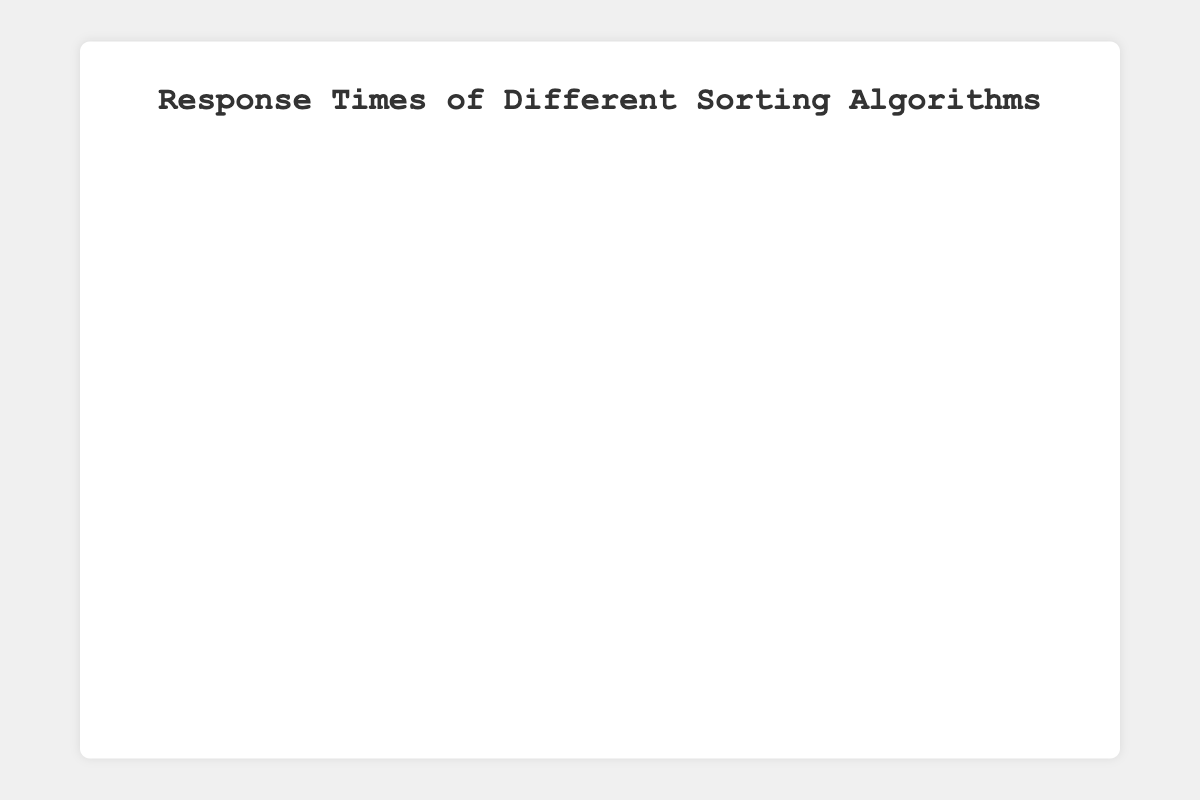What is the title of the chart? The title can be found at the top of the chart in a larger font size, and it typically provides an overview or description of what the chart is about. Here, the title reads "Response Times of Different Sorting Algorithms".
Answer: Response Times of Different Sorting Algorithms Which algorithm has the shortest response time for Input Size 1000? To find the shortest response time, look at the box plots for the Input Size 1000 data of each algorithm and compare their lower bounds. The lowest value can be seen in the QuickSort box plot.
Answer: QuickSort How does the median response time of BubbleSort change from Input Size 10 to Input Size 1000? Medians in box plots are indicated by the line inside the box. For BubbleSort, compare the lines for Input Size 10, 100, and 1000. The median increases progressively from 0.002 ms to 0.147 ms to 12.8 ms.
Answer: Increases significantly Which algorithm has the largest interquartile range (IQR) for Input Size 1000? The IQR is the distance between the bottom and top of the box (Q1 and Q3). Observing the box sizes, BubbleSort has the widest box, indicating the largest IQR.
Answer: BubbleSort How does MergeSort's response time compare to InsertionSort for Input Size 10? Compare the box plots of both algorithms for Input Size 10. The boxes for MergeSort are positioned lower on the y-axis compared to InsertionSort, indicating MergeSort has a faster response time.
Answer: MergeSort is faster Does the response time for InsertionSort increase more dramatically than for HeapSort as input size grows? By comparing the increase in response times between Input Size 10, 100, and 1000 for both algorithms, InsertionSort's response time rises more sharply. It increases from about 0.0018 ms to over 10.5 ms.
Answer: Yes Which algorithm shows the most consistent response times across different input sizes? The consistency of response times can be evaluated by the spread of the box plots. QuickSort has relatively smaller and tighter boxes across all input sizes, indicating consistent response times.
Answer: QuickSort What is the range of response times for BubbleSort with Input Size 100? The range can be found by subtracting the smallest value (min) from the largest value (max) in the box plot for Input Size 100 for BubbleSort. The smallest value is around 0.14 ms and the largest is around 0.16 ms.
Answer: 0.02 ms By how much does the median response time of MergeSort with Input Size 1000 differ from that of HeapSort with the same Input Size? Identify the median values in the box plots for both algorithms. For MergeSort, it's approximately 0.089 ms, and for HeapSort, it's approximately 0.085 ms. The difference is around 0.004 ms.
Answer: 0.004 ms 